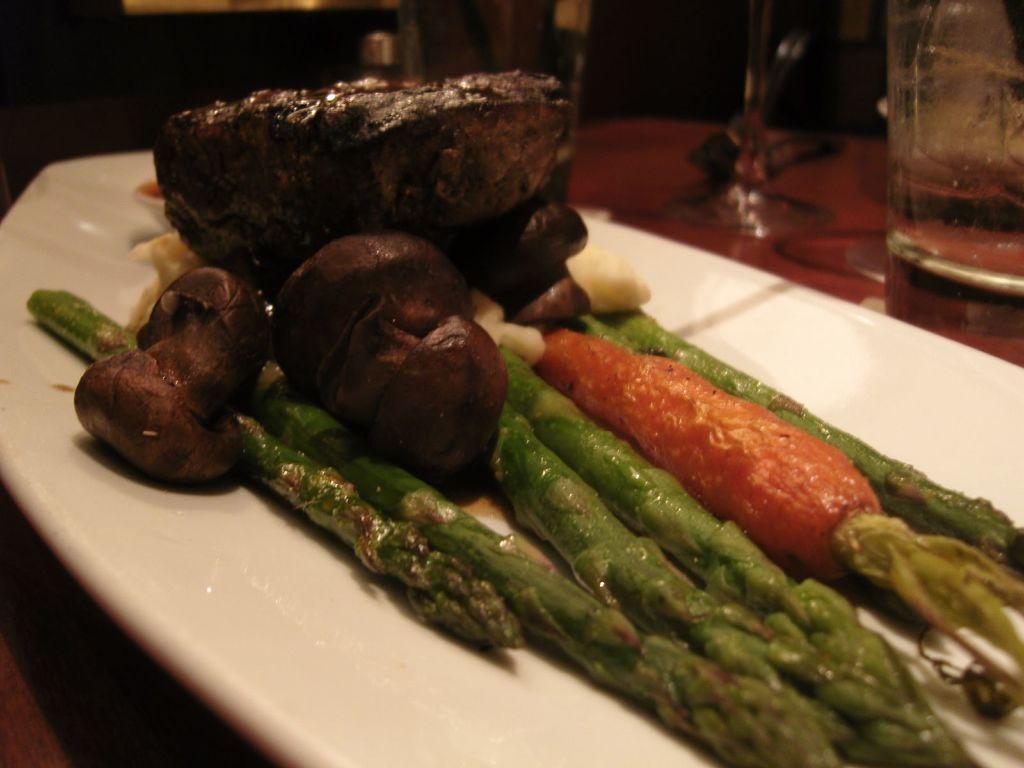Please provide a concise description of this image. In this image I can see there is a carrot cooked on the white color plate and other vegetables in it. On the right side there is a glass. 